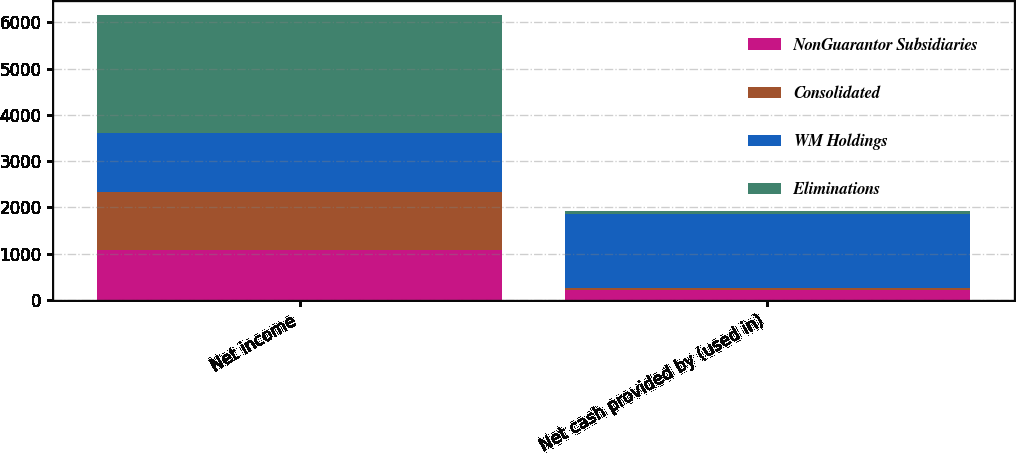Convert chart to OTSL. <chart><loc_0><loc_0><loc_500><loc_500><stacked_bar_chart><ecel><fcel>Net income<fcel>Net cash provided by (used in)<nl><fcel>NonGuarantor Subsidiaries<fcel>1087<fcel>225<nl><fcel>Consolidated<fcel>1254<fcel>40<nl><fcel>WM Holdings<fcel>1278<fcel>1589<nl><fcel>Eliminations<fcel>2532<fcel>68<nl></chart> 